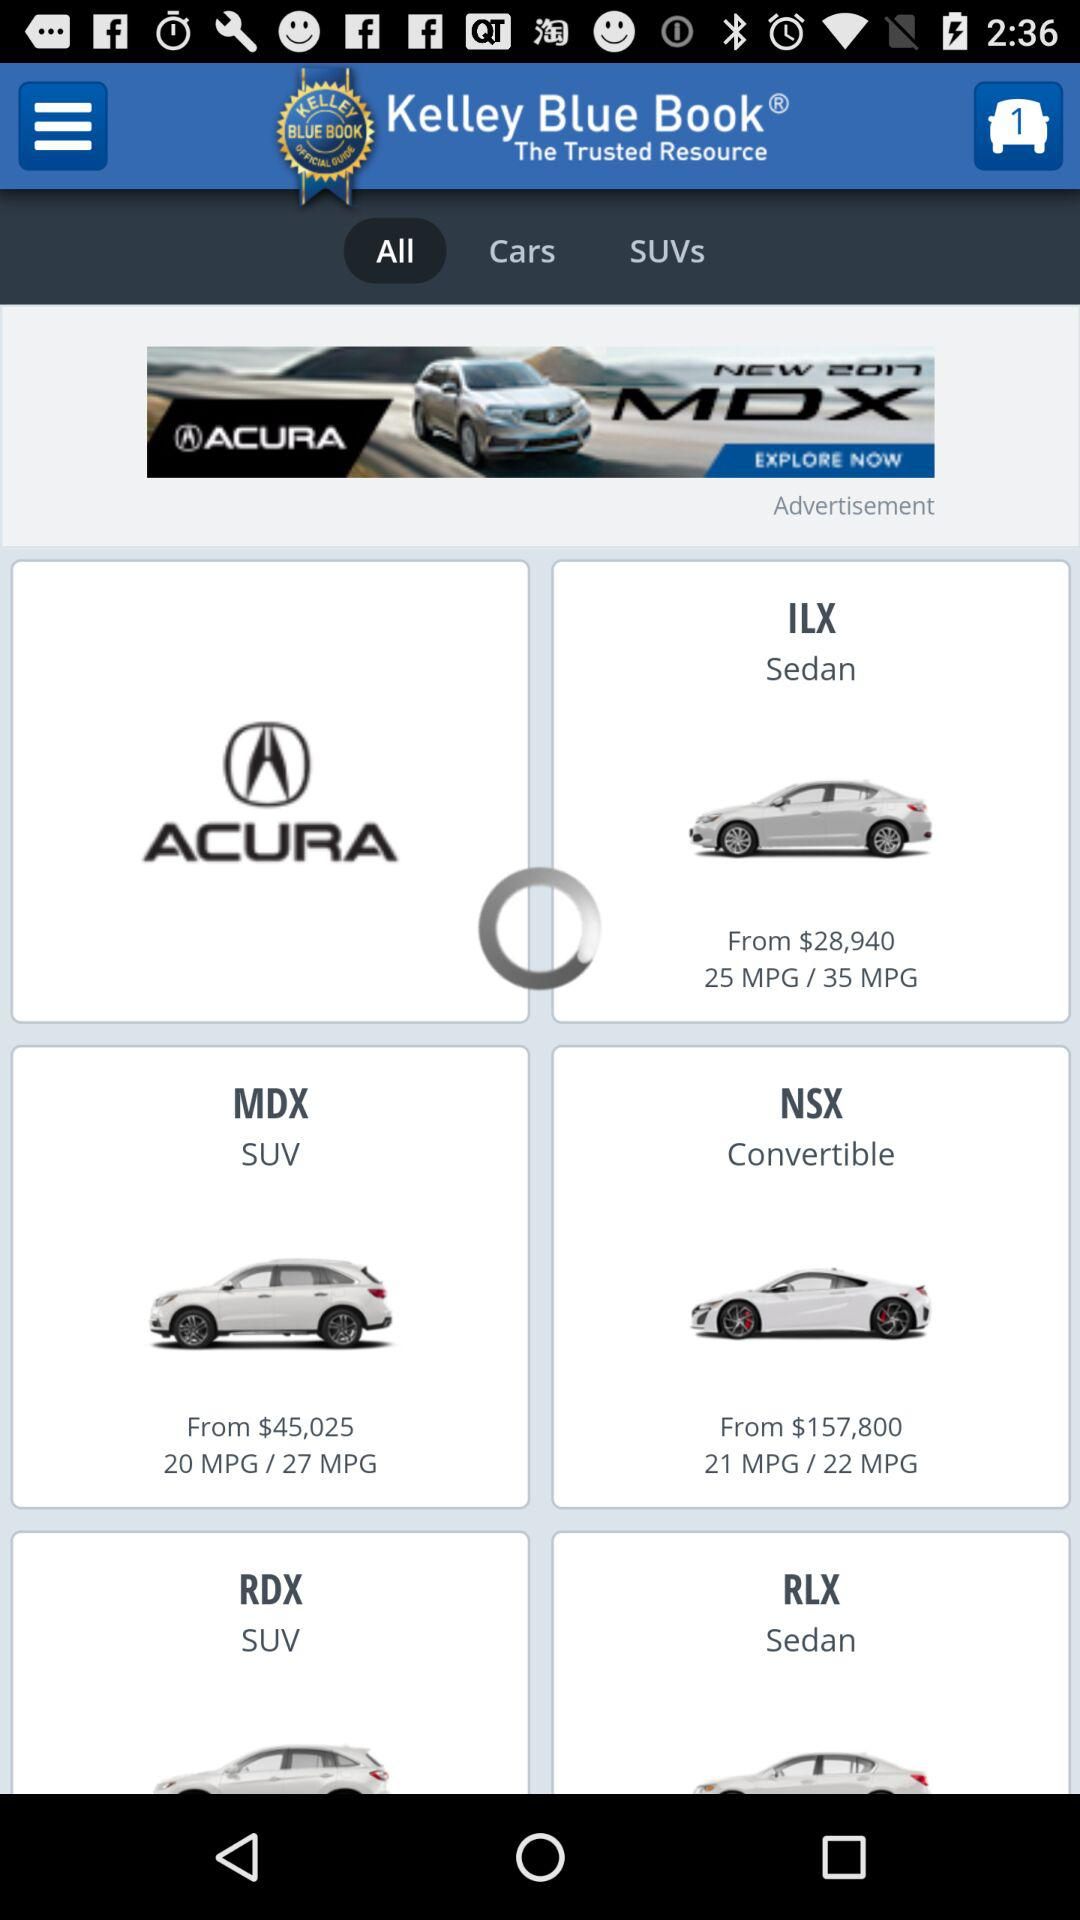How many more SUVs are there than sedans?
Answer the question using a single word or phrase. 2 